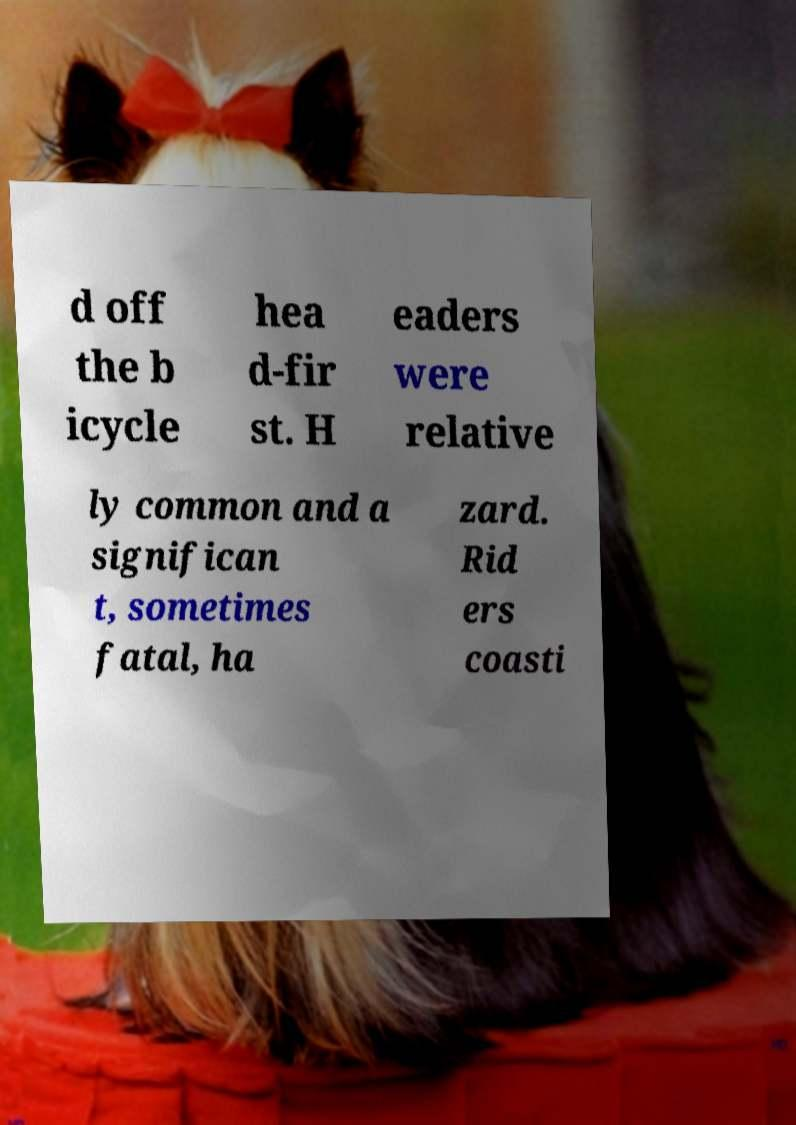Please read and relay the text visible in this image. What does it say? d off the b icycle hea d-fir st. H eaders were relative ly common and a significan t, sometimes fatal, ha zard. Rid ers coasti 